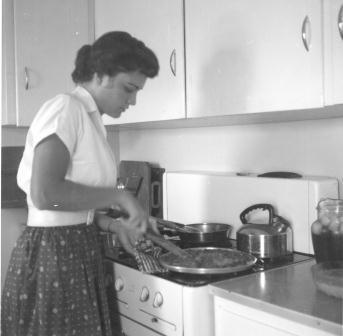How many giraffes are standing up?
Give a very brief answer. 0. 